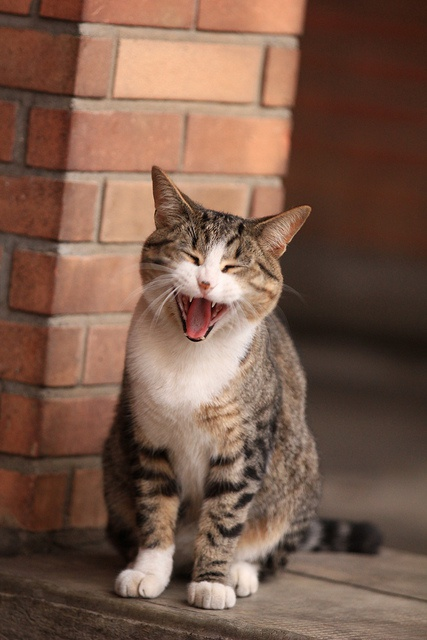Describe the objects in this image and their specific colors. I can see a cat in maroon, gray, black, and tan tones in this image. 